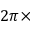Convert formula to latex. <formula><loc_0><loc_0><loc_500><loc_500>2 \pi \times</formula> 